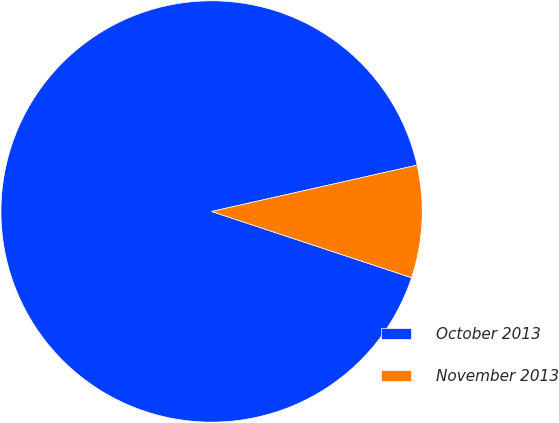Convert chart to OTSL. <chart><loc_0><loc_0><loc_500><loc_500><pie_chart><fcel>October 2013<fcel>November 2013<nl><fcel>91.38%<fcel>8.62%<nl></chart> 